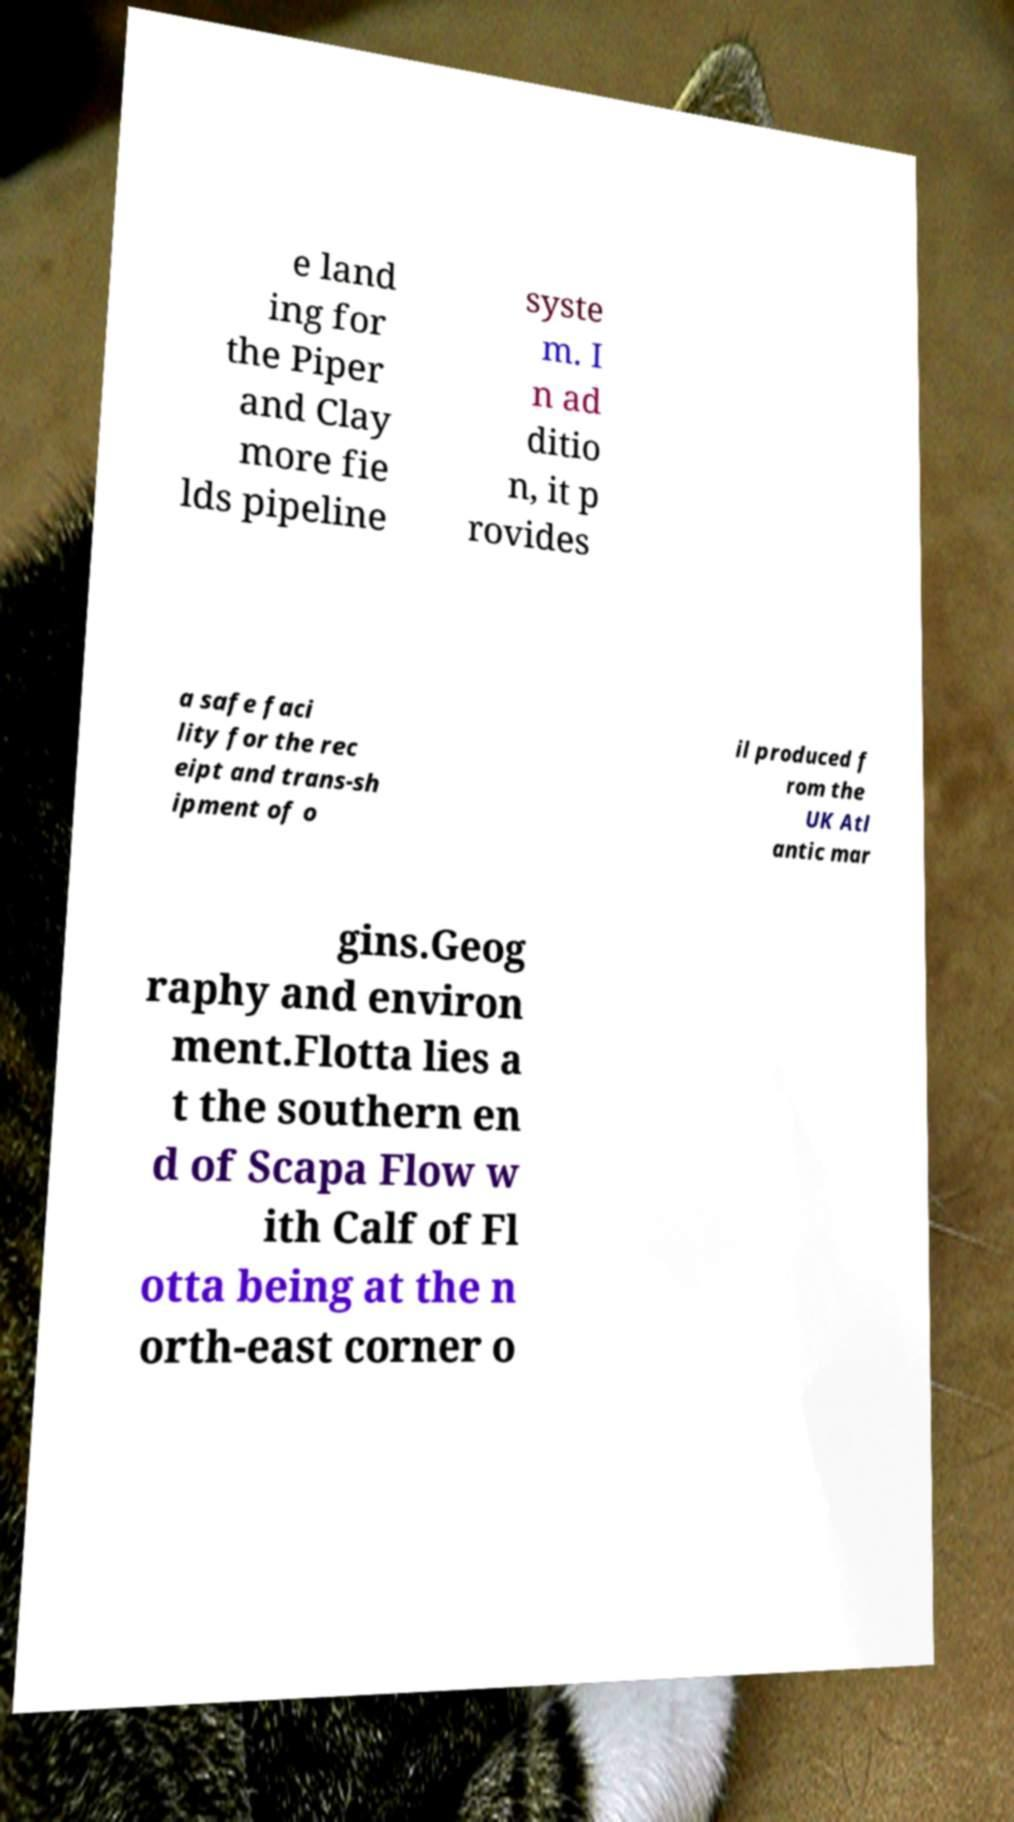Please identify and transcribe the text found in this image. e land ing for the Piper and Clay more fie lds pipeline syste m. I n ad ditio n, it p rovides a safe faci lity for the rec eipt and trans-sh ipment of o il produced f rom the UK Atl antic mar gins.Geog raphy and environ ment.Flotta lies a t the southern en d of Scapa Flow w ith Calf of Fl otta being at the n orth-east corner o 